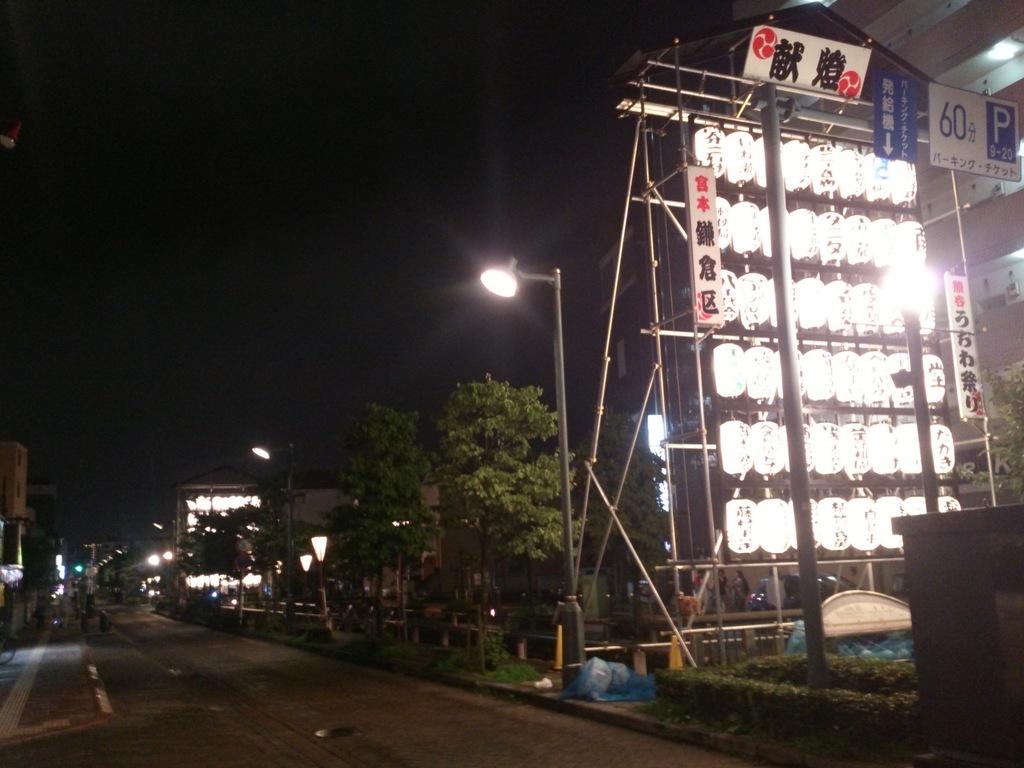What number is on the top right sign?
Keep it short and to the point. 60. What number is above all the lights?
Keep it short and to the point. 60. 